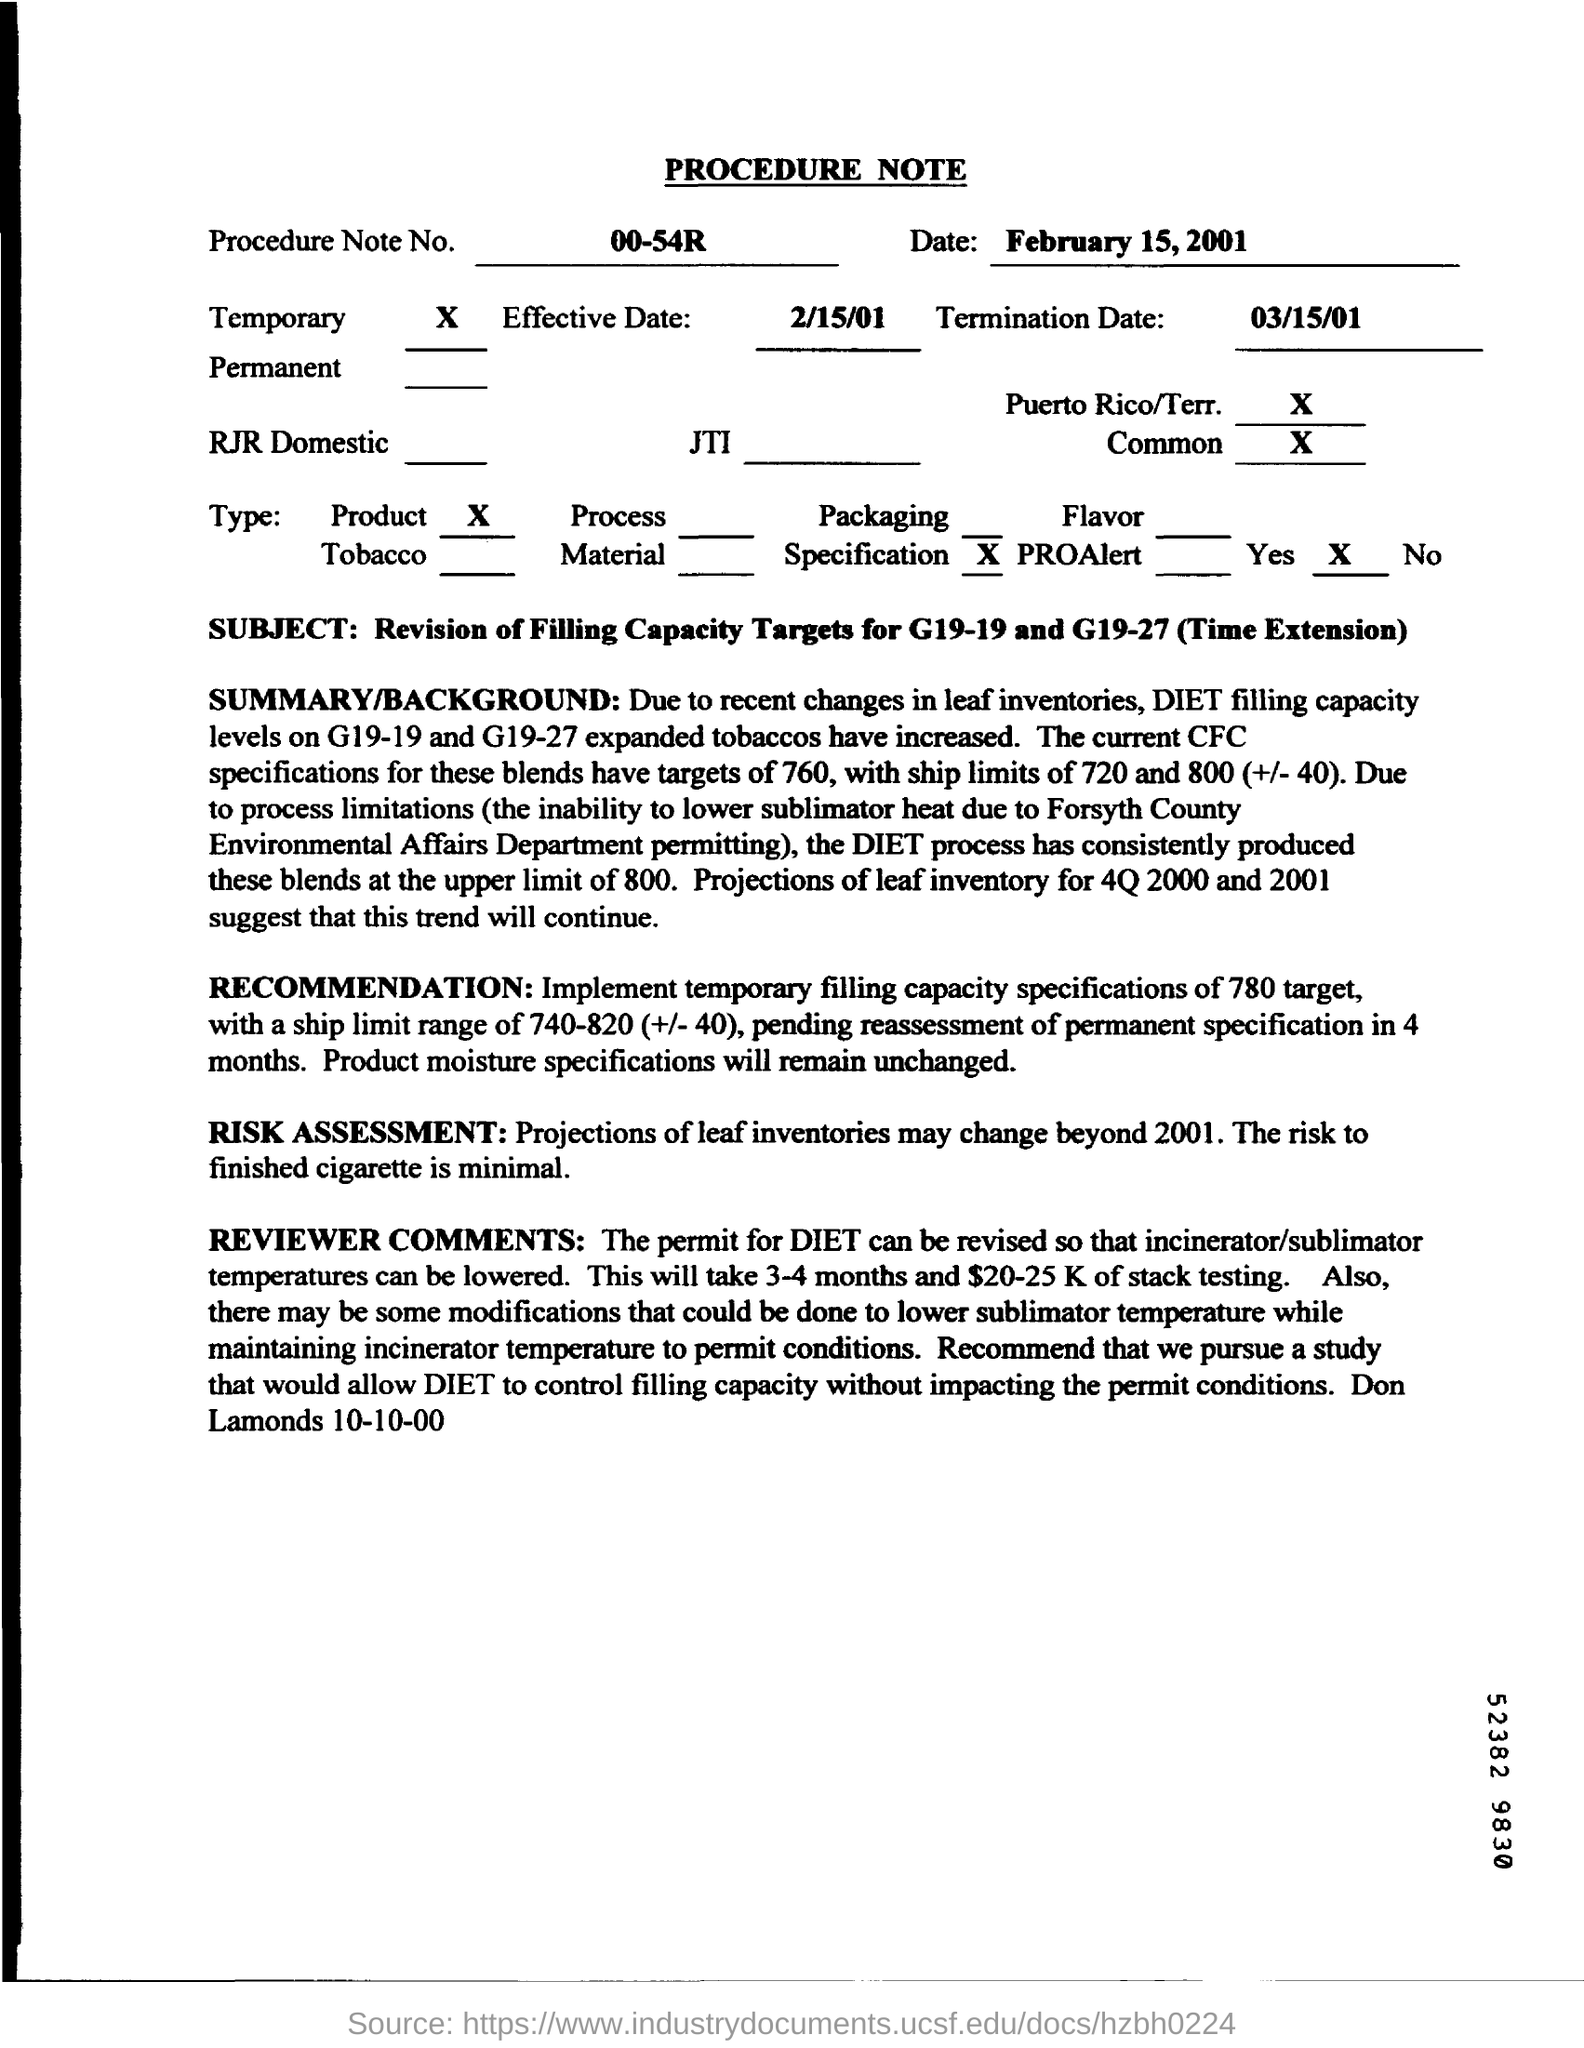Highlight a few significant elements in this photo. The time required for stack testing will be approximately 3-4 months. The subject mentioned in the procedure note is the revision of filling capacity targets for G19-19 and G19-27 (Time Extension). The procedure note number is 00-54R. In the recommendation, the product moisture specifications will remain unchanged. The revision of permits for DIET is necessary in order to lower the temperatures of the incinerator and sublimator. 